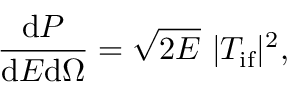<formula> <loc_0><loc_0><loc_500><loc_500>\frac { d P } { d E d \Omega } = \sqrt { 2 E } \ | T _ { { i f } } | ^ { 2 } ,</formula> 